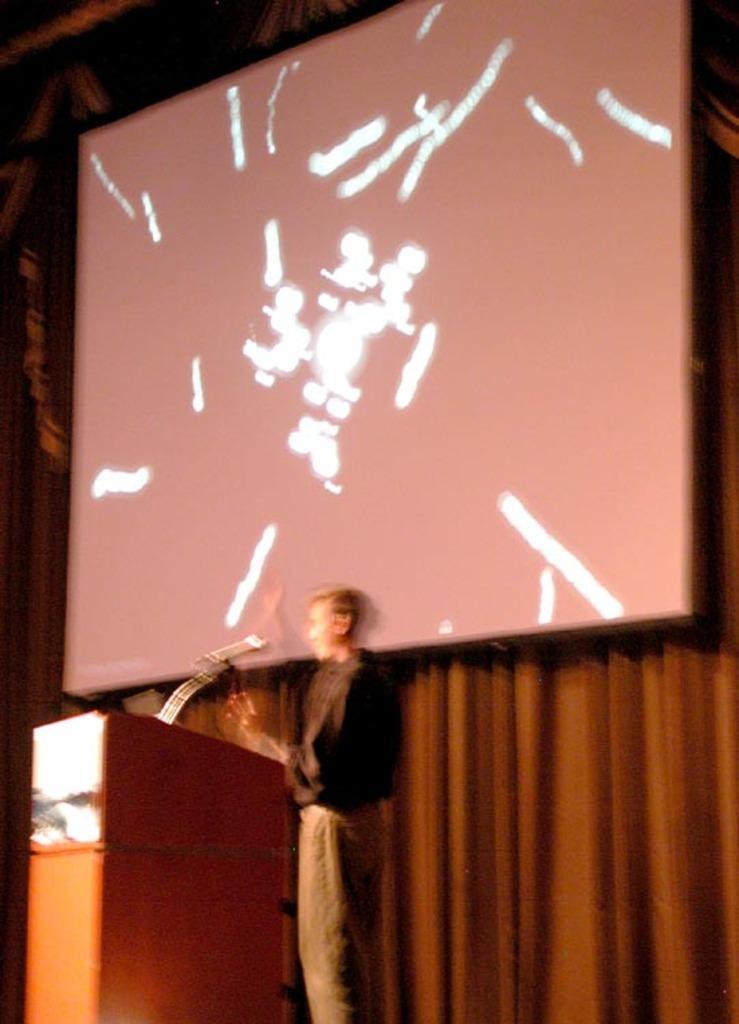How would you summarize this image in a sentence or two? In this image in the center there is one person who is standing, and in front of him there is podium and mike. And in the background there is a screen and curtain. 